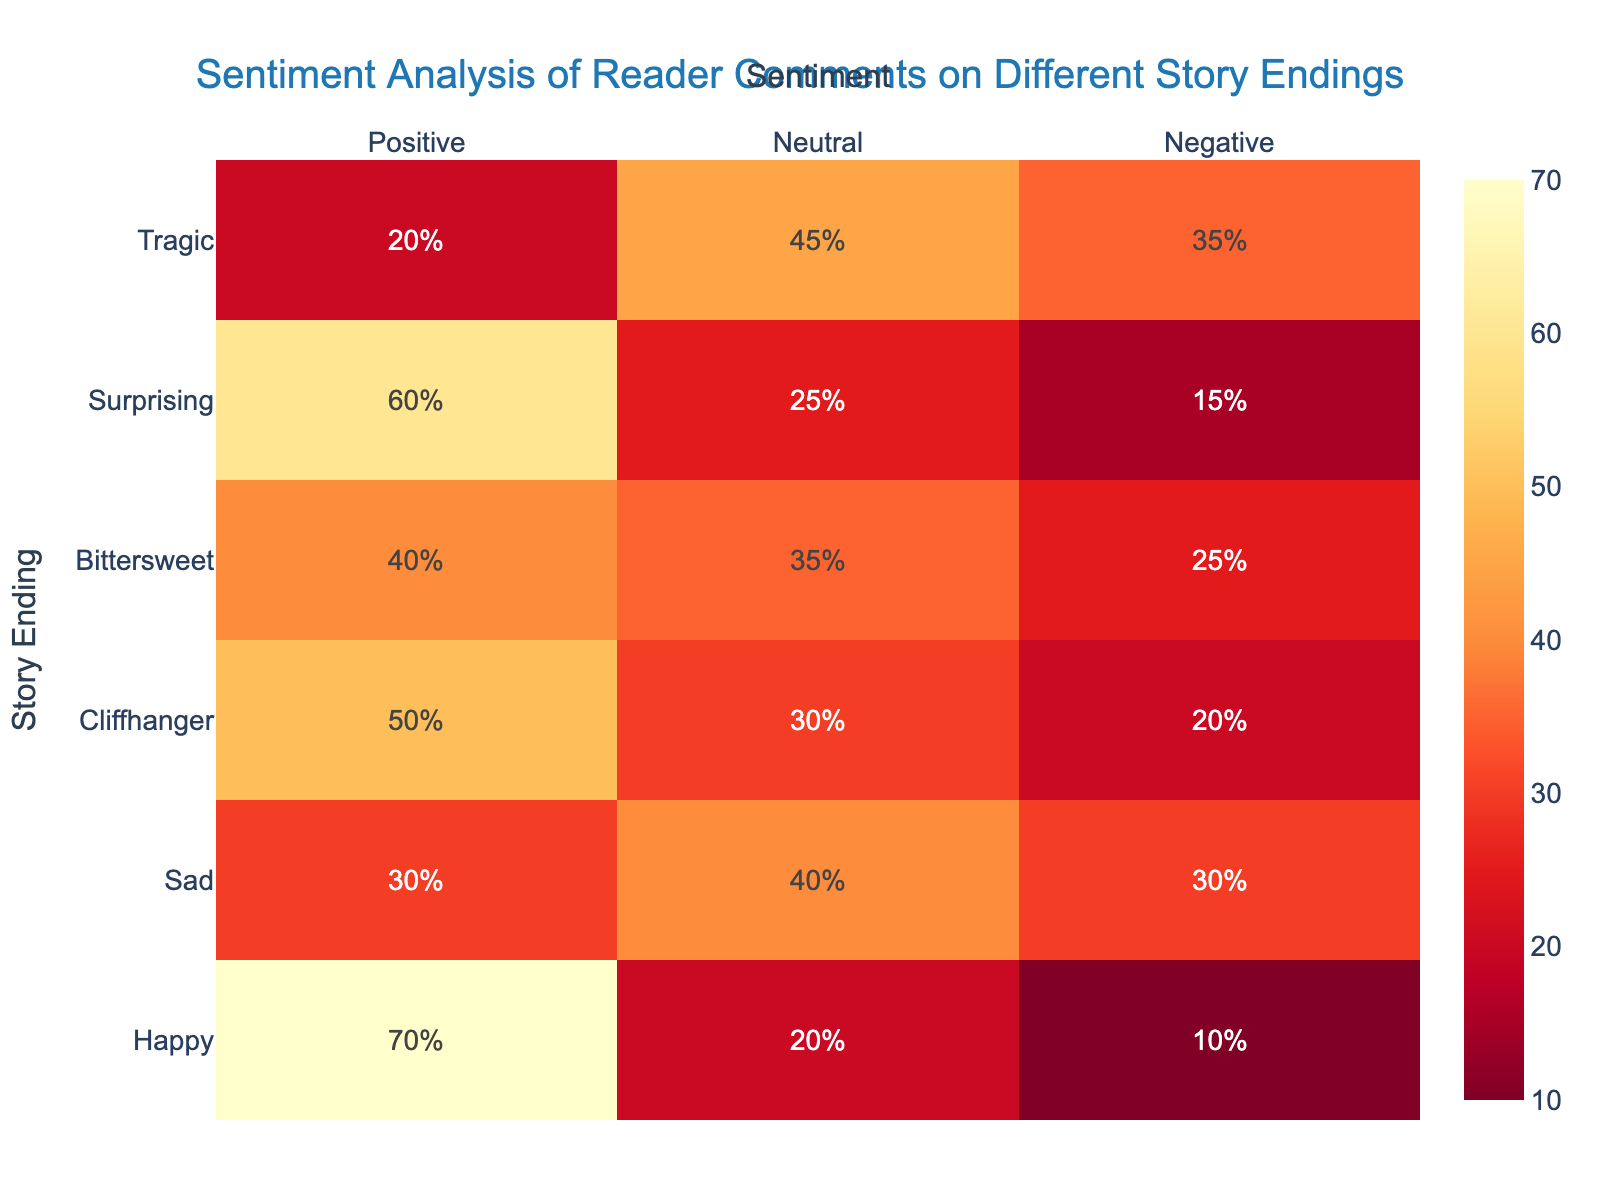What is the title of the heatmap? The title is located at the top of the heatmap and provides a summary of the figure's aim.
Answer: Sentiment Analysis of Reader Comments on Different Story Endings Which story ending has the highest positive sentiment? Look at the 'Positive' column and identify the story ending with the highest value.
Answer: Happy How many story endings have a higher positive sentiment than neutral sentiment? Compare the 'Positive' and 'Neutral' columns for each story ending and count the number of story endings where the positive sentiment is greater.
Answer: 5 What is the difference in negative sentiment between the 'Sad' and 'Tragic' endings? Subtract the negative sentiment of 'Sad' from 'Tragic': 35% - 30% = 5%.
Answer: 5% Which sentiment category has the smallest number of comments for the 'Bittersweet' ending? For 'Bittersweet', compare the values in the 'Positive', 'Neutral', and 'Negative' columns and find the smallest one.
Answer: Negative How does the neutral sentiment for 'Cliffhanger' compare to that for 'Bittersweet'? Compare the 'Neutral' values for both 'Cliffhanger' (30%) and 'Bittersweet' (35%).
Answer: Bittersweet is higher by 5% Which story ending has the highest negative sentiment? Look at the 'Negative' column and identify the story ending with the highest percentage.
Answer: Tragic What is the sum of positive sentiment percentages for all story endings? Add up the values in the 'Positive' column: 70 + 30 + 50 + 40 + 60 + 20 = 270
Answer: 270% How does the positive sentiment for 'Surprising' compare to that of 'Sad'? Subtract the positive sentiment of 'Sad' from 'Surprising': 60% - 30% = 30%.
Answer: 30% higher What is the average neutral sentiment for all story endings? Sum the 'Neutral' values and divide by the number of story endings: (20 + 40 + 30 + 35 + 25 + 45) / 6 = 195 / 6 ≈ 32.5
Answer: 32.5% 